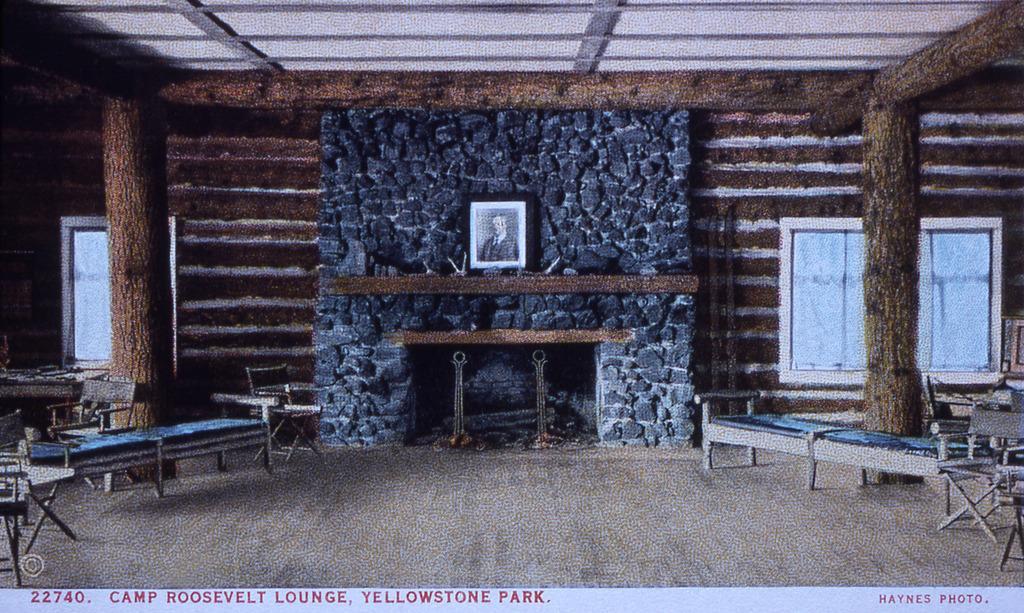Could you give a brief overview of what you see in this image? In the picture we can see a house inside it, we can see a tree branch pillars and a wall with rocks and on the floor, we can see some chairs and tables and to into the wall we can see a photo frame. 